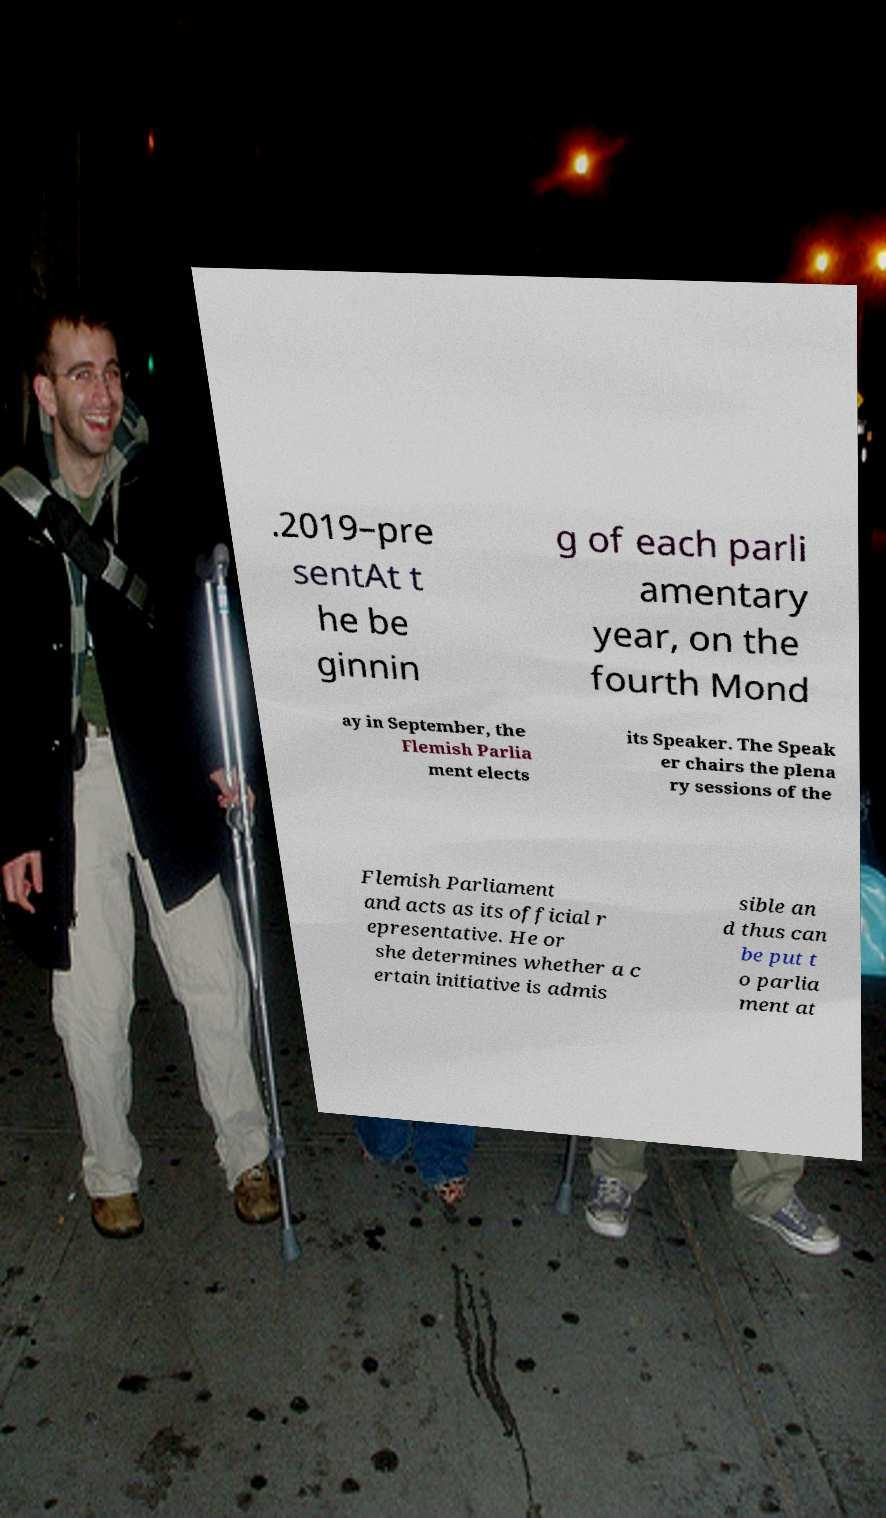I need the written content from this picture converted into text. Can you do that? .2019–pre sentAt t he be ginnin g of each parli amentary year, on the fourth Mond ay in September, the Flemish Parlia ment elects its Speaker. The Speak er chairs the plena ry sessions of the Flemish Parliament and acts as its official r epresentative. He or she determines whether a c ertain initiative is admis sible an d thus can be put t o parlia ment at 